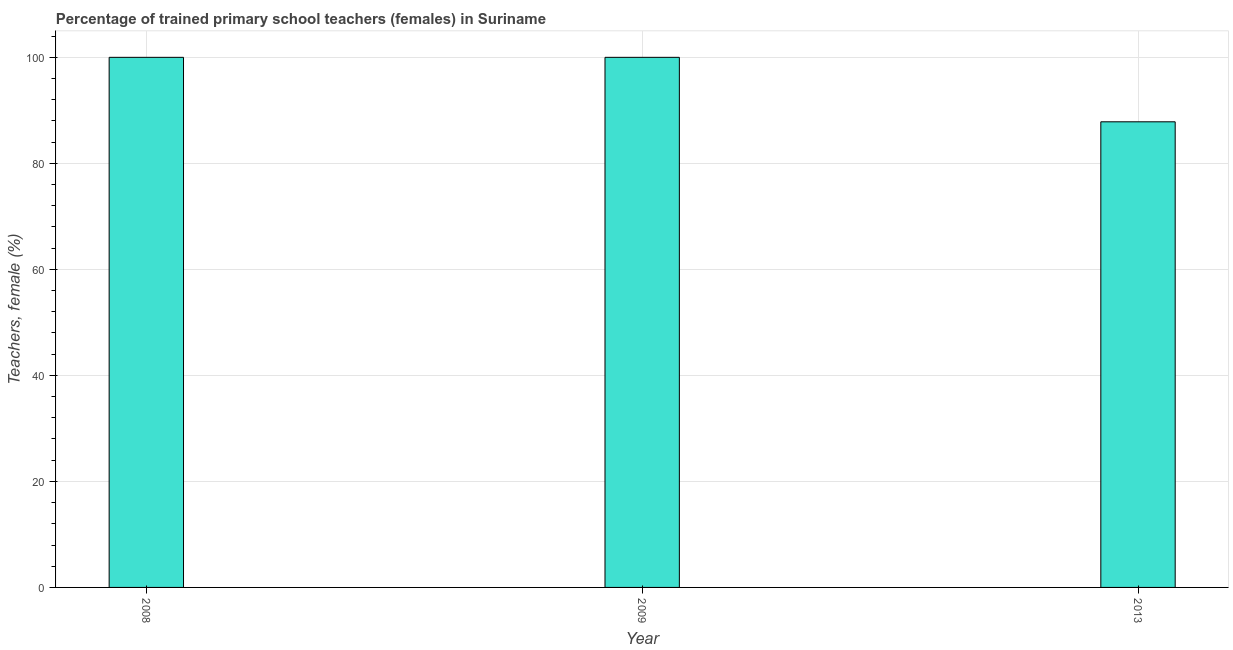Does the graph contain any zero values?
Offer a very short reply. No. Does the graph contain grids?
Ensure brevity in your answer.  Yes. What is the title of the graph?
Make the answer very short. Percentage of trained primary school teachers (females) in Suriname. What is the label or title of the X-axis?
Ensure brevity in your answer.  Year. What is the label or title of the Y-axis?
Ensure brevity in your answer.  Teachers, female (%). What is the percentage of trained female teachers in 2008?
Offer a terse response. 100. Across all years, what is the maximum percentage of trained female teachers?
Give a very brief answer. 100. Across all years, what is the minimum percentage of trained female teachers?
Give a very brief answer. 87.84. In which year was the percentage of trained female teachers minimum?
Give a very brief answer. 2013. What is the sum of the percentage of trained female teachers?
Give a very brief answer. 287.84. What is the difference between the percentage of trained female teachers in 2009 and 2013?
Provide a short and direct response. 12.16. What is the average percentage of trained female teachers per year?
Offer a terse response. 95.95. In how many years, is the percentage of trained female teachers greater than 36 %?
Make the answer very short. 3. What is the ratio of the percentage of trained female teachers in 2009 to that in 2013?
Offer a very short reply. 1.14. Is the difference between the percentage of trained female teachers in 2008 and 2013 greater than the difference between any two years?
Make the answer very short. Yes. What is the difference between the highest and the second highest percentage of trained female teachers?
Offer a very short reply. 0. What is the difference between the highest and the lowest percentage of trained female teachers?
Your answer should be very brief. 12.16. In how many years, is the percentage of trained female teachers greater than the average percentage of trained female teachers taken over all years?
Make the answer very short. 2. Are all the bars in the graph horizontal?
Your answer should be compact. No. How many years are there in the graph?
Your answer should be compact. 3. What is the difference between two consecutive major ticks on the Y-axis?
Offer a terse response. 20. Are the values on the major ticks of Y-axis written in scientific E-notation?
Your answer should be very brief. No. What is the Teachers, female (%) of 2009?
Make the answer very short. 100. What is the Teachers, female (%) of 2013?
Keep it short and to the point. 87.84. What is the difference between the Teachers, female (%) in 2008 and 2009?
Your response must be concise. 0. What is the difference between the Teachers, female (%) in 2008 and 2013?
Your response must be concise. 12.16. What is the difference between the Teachers, female (%) in 2009 and 2013?
Give a very brief answer. 12.16. What is the ratio of the Teachers, female (%) in 2008 to that in 2013?
Provide a succinct answer. 1.14. What is the ratio of the Teachers, female (%) in 2009 to that in 2013?
Provide a succinct answer. 1.14. 